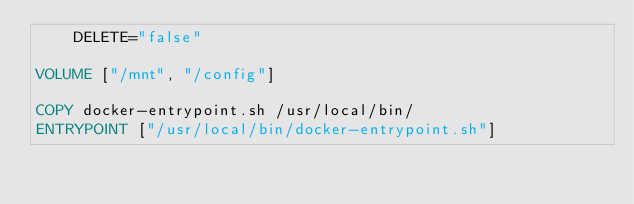<code> <loc_0><loc_0><loc_500><loc_500><_Dockerfile_>	DELETE="false"

VOLUME ["/mnt", "/config"]

COPY docker-entrypoint.sh /usr/local/bin/
ENTRYPOINT ["/usr/local/bin/docker-entrypoint.sh"]</code> 